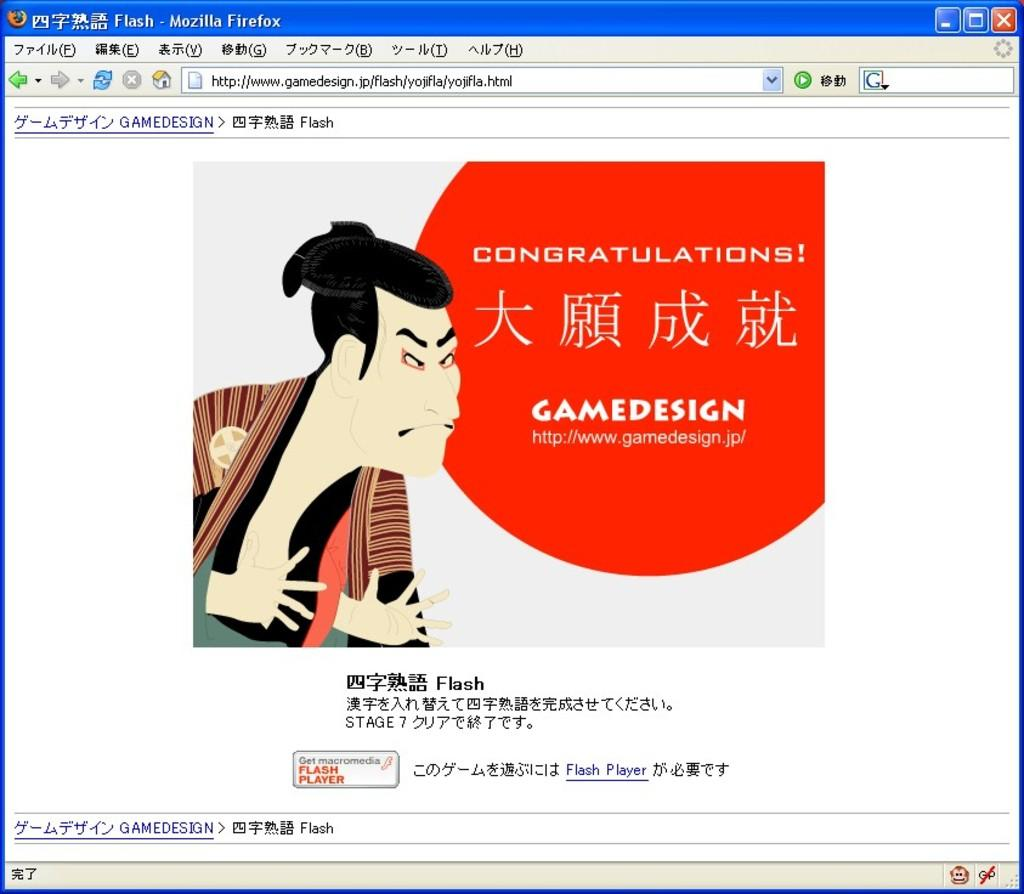What type of image is present on the web page? There is a cartoon image on the web page. What can be found on the cartoon image? There is text written on the cartoon image. What other elements are present on the web page? There are different icons on the web page. How many sisters are depicted in the cartoon image on the web page? There are no sisters depicted in the cartoon image on the web page, as the image does not contain any human figures. Can you see any pigs in the cartoon image? There are no pigs present in the cartoon image on the web page. 